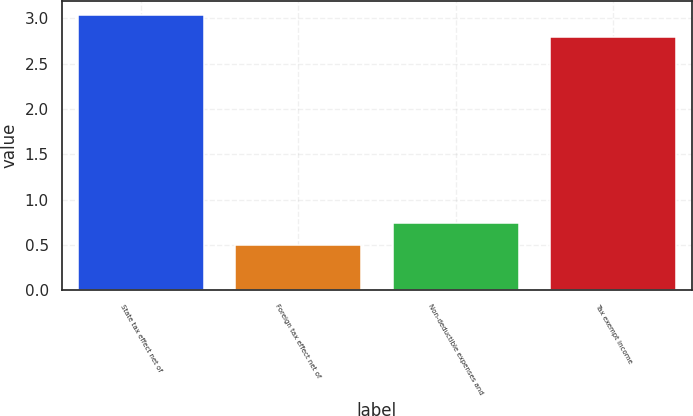Convert chart to OTSL. <chart><loc_0><loc_0><loc_500><loc_500><bar_chart><fcel>State tax effect net of<fcel>Foreign tax effect net of<fcel>Non-deductible expenses and<fcel>Tax exempt income<nl><fcel>3.04<fcel>0.5<fcel>0.74<fcel>2.8<nl></chart> 